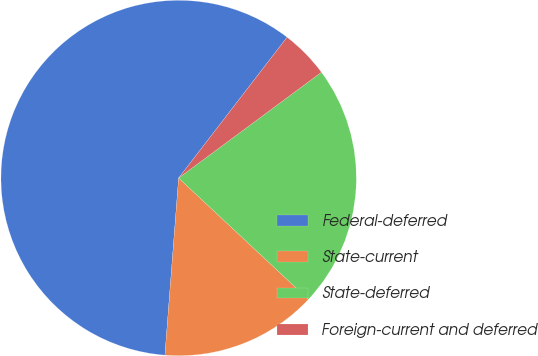<chart> <loc_0><loc_0><loc_500><loc_500><pie_chart><fcel>Federal-deferred<fcel>State-current<fcel>State-deferred<fcel>Foreign-current and deferred<nl><fcel>59.22%<fcel>14.26%<fcel>22.12%<fcel>4.41%<nl></chart> 